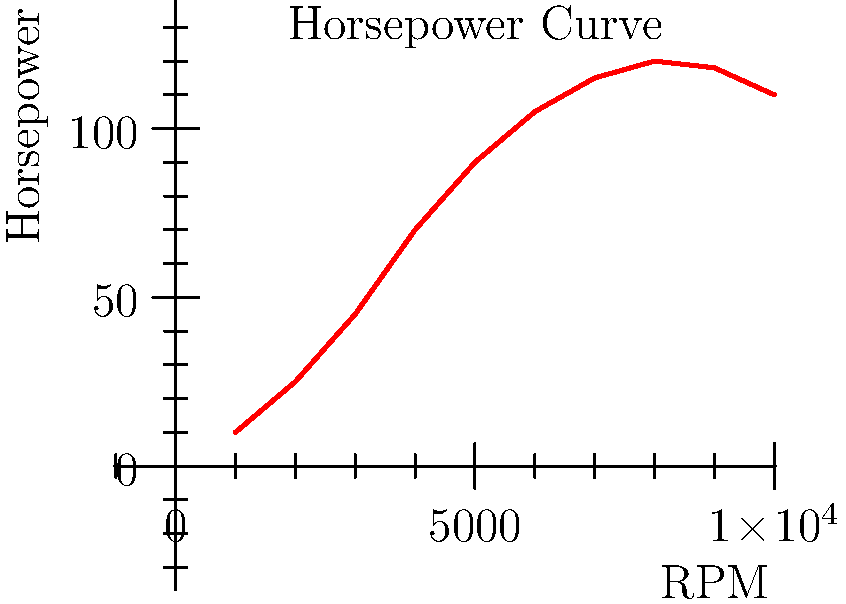Given the horsepower curve of a motorcycle engine shown in the graph, calculate the peak torque in lb-ft at 6000 RPM. Assume the conversion factor from horsepower to torque is: Torque (lb-ft) = (Horsepower × 5252) / RPM. To calculate the torque at 6000 RPM, we'll follow these steps:

1. Identify the horsepower at 6000 RPM from the graph:
   At 6000 RPM, the horsepower is approximately 105 HP.

2. Use the conversion formula:
   Torque (lb-ft) = (Horsepower × 5252) / RPM

3. Plug in the values:
   Torque = (105 × 5252) / 6000

4. Calculate:
   Torque = 551,460 / 6000 = 91.91 lb-ft

5. Round to the nearest whole number:
   Torque ≈ 92 lb-ft

Therefore, the peak torque at 6000 RPM is approximately 92 lb-ft.

Note: This calculation gives us the torque at a specific point (6000 RPM). To find the complete torque curve, we would need to perform this calculation for each point on the horsepower curve.
Answer: 92 lb-ft 